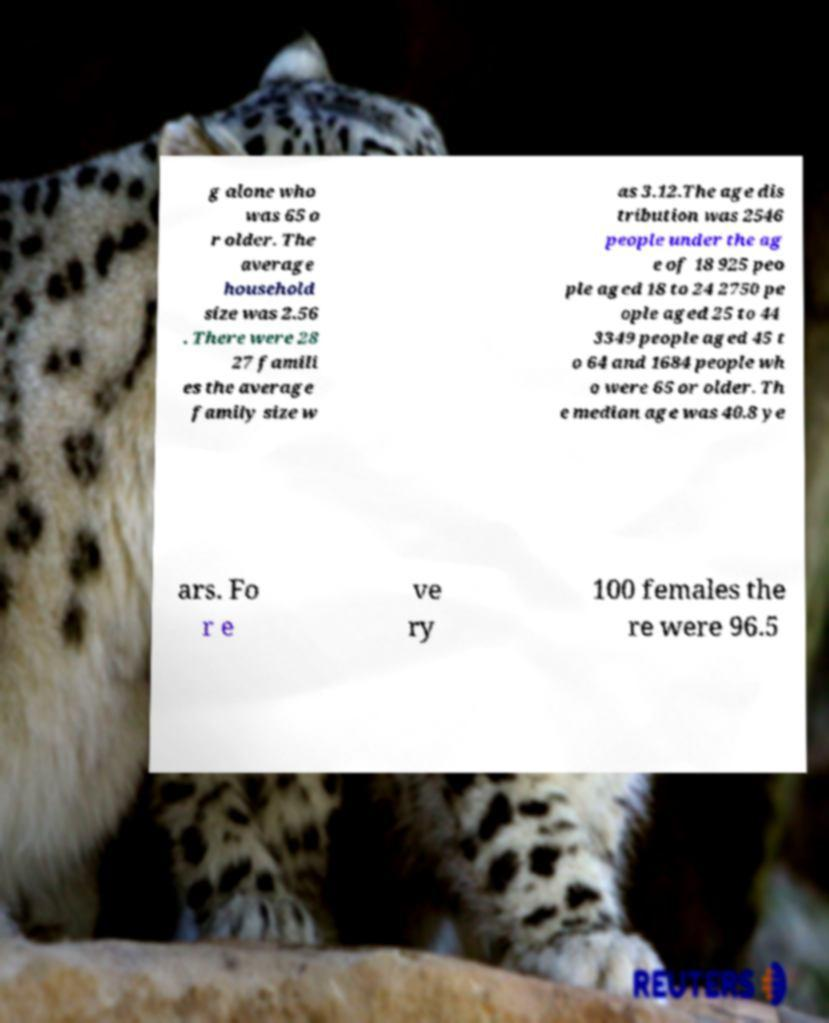What messages or text are displayed in this image? I need them in a readable, typed format. g alone who was 65 o r older. The average household size was 2.56 . There were 28 27 famili es the average family size w as 3.12.The age dis tribution was 2546 people under the ag e of 18 925 peo ple aged 18 to 24 2750 pe ople aged 25 to 44 3349 people aged 45 t o 64 and 1684 people wh o were 65 or older. Th e median age was 40.8 ye ars. Fo r e ve ry 100 females the re were 96.5 